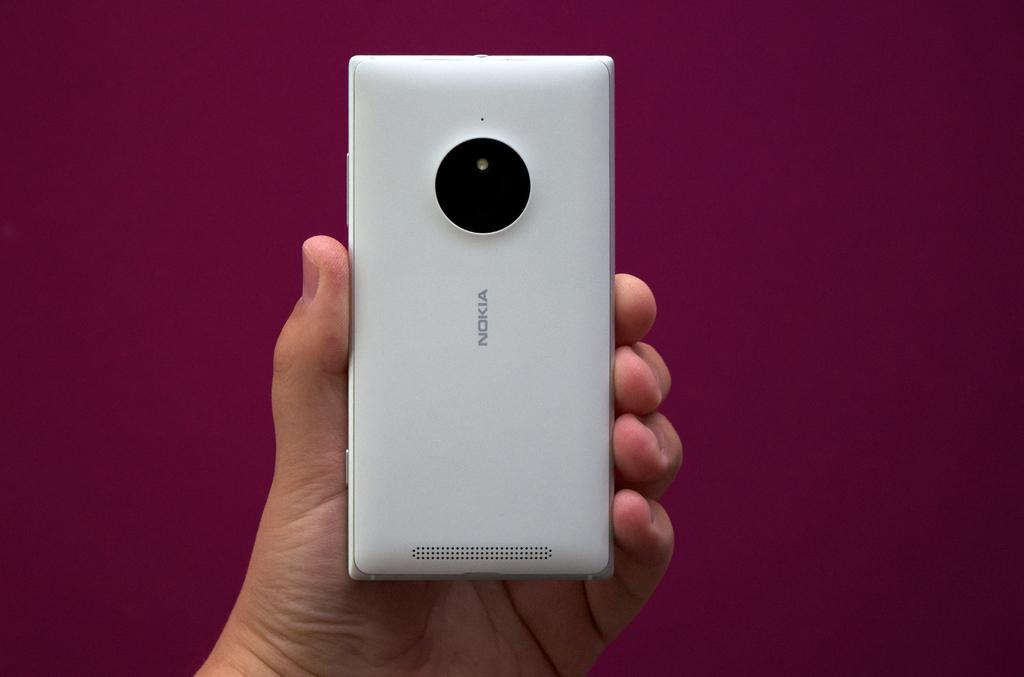<image>
Relay a brief, clear account of the picture shown. A hand holding up a Nokia device with a purple background. 